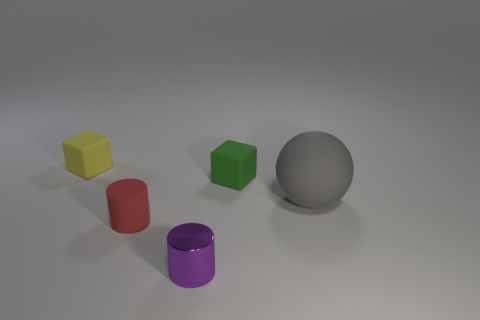Subtract 2 cylinders. How many cylinders are left? 0 Subtract all blocks. How many objects are left? 3 Add 5 tiny green matte cubes. How many tiny green matte cubes are left? 6 Add 1 large spheres. How many large spheres exist? 2 Add 4 small yellow rubber cylinders. How many objects exist? 9 Subtract all green cubes. How many cubes are left? 1 Subtract 0 gray cylinders. How many objects are left? 5 Subtract all yellow cylinders. Subtract all brown balls. How many cylinders are left? 2 Subtract all purple spheres. How many yellow cylinders are left? 0 Subtract all big green things. Subtract all gray things. How many objects are left? 4 